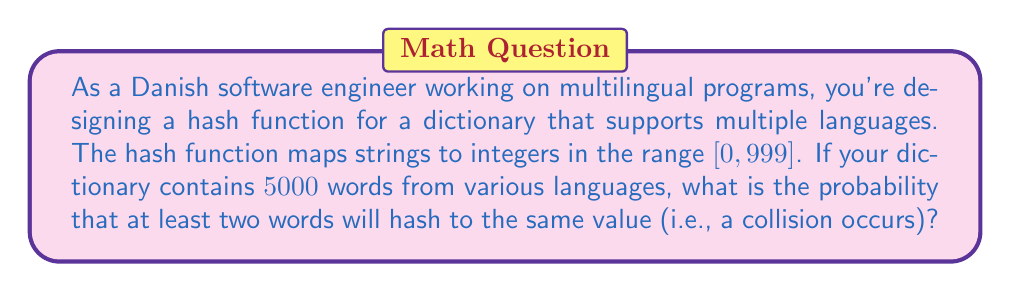Give your solution to this math problem. To solve this problem, we'll use the concept of the birthday paradox and calculate the probability of no collisions, then subtract it from 1 to get the probability of at least one collision.

Let's approach this step-by-step:

1) First, we need to calculate the probability of no collisions. This is equivalent to the probability that all 5000 words hash to different values.

2) The probability of the first word hashing to any value is 1, as all slots are empty.

3) The probability of the second word not colliding is $\frac{999}{1000}$, as 999 slots are still available.

4) For the third word, the probability is $\frac{998}{1000}$, and so on.

5) Therefore, the probability of no collisions is:

   $$P(\text{no collisions}) = 1 \cdot \frac{999}{1000} \cdot \frac{998}{1000} \cdot ... \cdot \frac{1000-4999}{1000}$$

6) This can be written more compactly as:

   $$P(\text{no collisions}) = \frac{1000!}{(1000-5000)! \cdot 1000^{5000}}$$

   Note that $(1000-5000)!$ is undefined in real numbers, but we can interpret this as 1 in this context.

7) The probability of at least one collision is the complement of this:

   $$P(\text{at least one collision}) = 1 - P(\text{no collisions})$$

8) Calculating this exactly would result in a very small number (very close to 1), so we can use logarithms to make the computation more manageable:

   $$\log(P(\text{no collisions})) = \log(1000!) - 5000\log(1000)$$

9) Using Stirling's approximation for the factorial and computing:

   $$\log(P(\text{no collisions})) \approx -11051.5$$

10) Therefore:

    $$P(\text{no collisions}) \approx e^{-11051.5} \approx 0$$

11) Thus, $P(\text{at least one collision}) \approx 1 - 0 = 1$
Answer: The probability of at least one collision is approximately 1 (or 100%). 